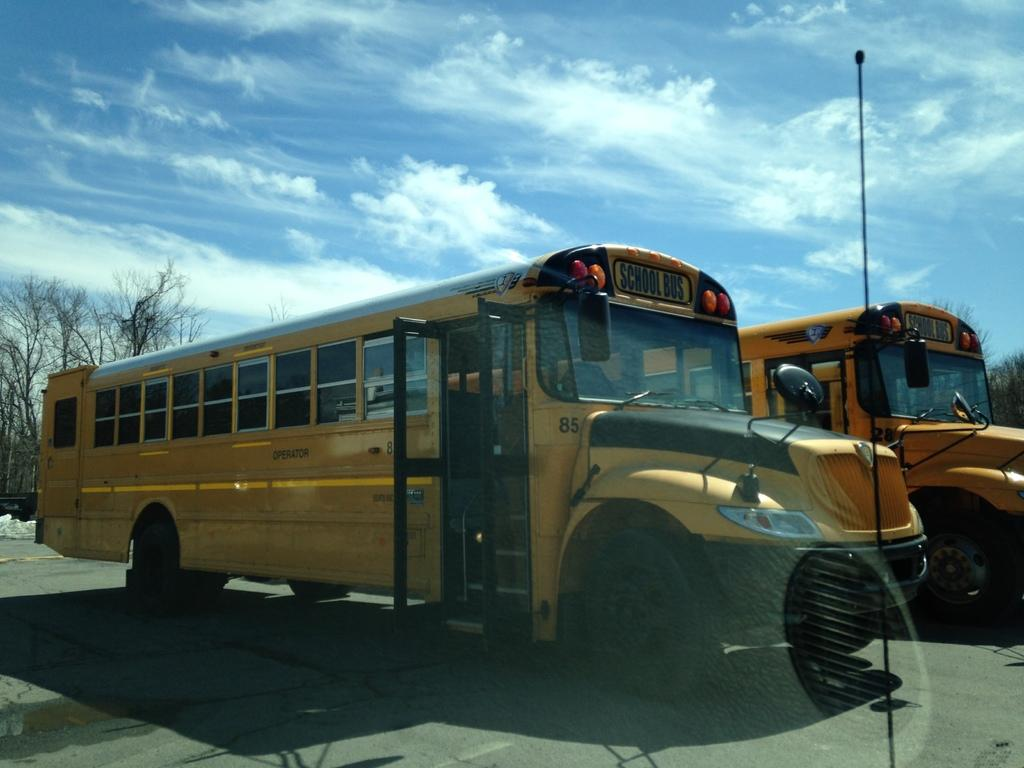What type of vehicles can be seen on the road in the image? There are buses on a road in the image. What can be seen in the background of the image? There are trees and the sky in the background of the image. What color is the sky in the image? The sky is blue in the background of the image. What type of attraction can be seen in the image? There is no attraction present in the image; it features buses on a road with trees and a blue sky in the background. What tool is used to comb the buses in the image? There is no comb or any tool used to interact with the buses in the image; they are simply parked on the road. 